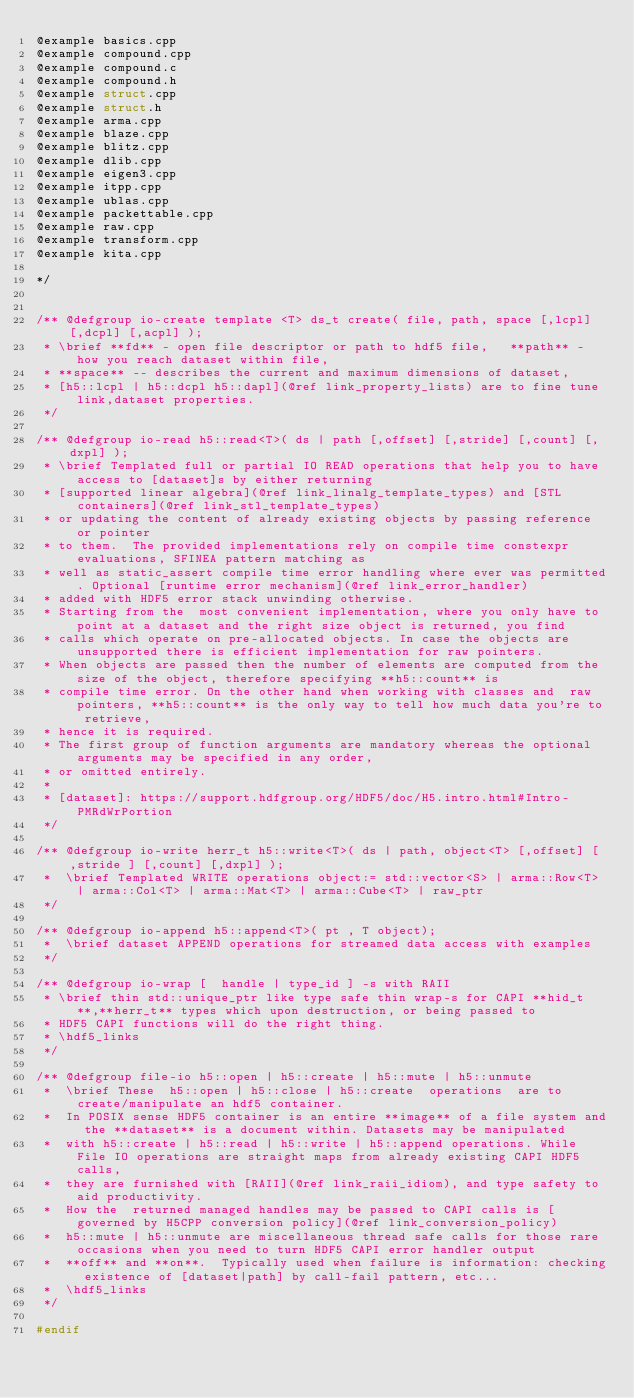Convert code to text. <code><loc_0><loc_0><loc_500><loc_500><_C++_>@example basics.cpp
@example compound.cpp
@example compound.c
@example compound.h
@example struct.cpp
@example struct.h
@example arma.cpp
@example blaze.cpp
@example blitz.cpp
@example dlib.cpp
@example eigen3.cpp
@example itpp.cpp
@example ublas.cpp
@example packettable.cpp
@example raw.cpp
@example transform.cpp
@example kita.cpp

*/


/** @defgroup io-create template <T> ds_t create( file, path, space [,lcpl] [,dcpl] [,acpl] );
 * \brief **fd** - open file descriptor or path to hdf5 file,   **path** - how you reach dataset within file, 
 * **space** -- describes the current and maximum dimensions of dataset, 
 * [h5::lcpl | h5::dcpl h5::dapl](@ref link_property_lists) are to fine tune link,dataset properties.
 */

/** @defgroup io-read h5::read<T>( ds | path [,offset] [,stride] [,count] [,dxpl] ); 
 * \brief Templated full or partial IO READ operations that help you to have access to [dataset]s by either returning 
 * [supported linear algebra](@ref link_linalg_template_types) and [STL containers](@ref link_stl_template_types) 
 * or updating the content of already existing objects by passing reference or pointer 
 * to them.  The provided implementations rely on compile time constexpr evaluations, SFINEA pattern matching as 
 * well as static_assert compile time error handling where ever was permitted. Optional [runtime error mechanism](@ref link_error_handler)
 * added with HDF5 error stack unwinding otherwise. 
 * Starting from the  most convenient implementation, where you only have to point at a dataset and the right size object is returned, you find 
 * calls which operate on pre-allocated objects. In case the objects are unsupported there is efficient implementation for raw pointers.
 * When objects are passed then the number of elements are computed from the size of the object, therefore specifying **h5::count** is 
 * compile time error. On the other hand when working with classes and  raw pointers, **h5::count** is the only way to tell how much data you're to retrieve,
 * hence it is required.   
 * The first group of function arguments are mandatory whereas the optional arguments may be specified in any order, 
 * or omitted entirely.
 *
 * [dataset]: https://support.hdfgroup.org/HDF5/doc/H5.intro.html#Intro-PMRdWrPortion 
 */

/** @defgroup io-write herr_t h5::write<T>( ds | path, object<T> [,offset] [ ,stride ] [,count] [,dxpl] );
 *  \brief Templated WRITE operations object:= std::vector<S> | arma::Row<T> | arma::Col<T> | arma::Mat<T> | arma::Cube<T> | raw_ptr 
 */

/** @defgroup io-append h5::append<T>( pt , T object);
 *  \brief dataset APPEND operations for streamed data access with examples
 */

/** @defgroup io-wrap [  handle | type_id ] -s with RAII
 * \brief thin std::unique_ptr like type safe thin wrap-s for CAPI **hid_t**,**herr_t** types which upon destruction, or being passed to 
 * HDF5 CAPI functions will do the right thing. 
 * \hdf5_links
 */

/** @defgroup file-io h5::open | h5::create | h5::mute | h5::unmute
 *  \brief These  h5::open | h5::close | h5::create  operations  are to create/manipulate an hdf5 container. 
 *  In POSIX sense HDF5 container is an entire **image** of a file system and the **dataset** is a document within. Datasets may be manipulated
 *  with h5::create | h5::read | h5::write | h5::append operations. While File IO operations are straight maps from already existing CAPI HDF5 calls, 
 *  they are furnished with [RAII](@ref link_raii_idiom), and type safety to aid productivity. 
 *  How the  returned managed handles may be passed to CAPI calls is [governed by H5CPP conversion policy](@ref link_conversion_policy) 
 *  h5::mute | h5::unmute are miscellaneous thread safe calls for those rare occasions when you need to turn HDF5 CAPI error handler output
 *  **off** and **on**.  Typically used when failure is information: checking existence of [dataset|path] by call-fail pattern, etc...  
 *  \hdf5_links
 */

#endif





</code> 